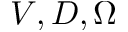Convert formula to latex. <formula><loc_0><loc_0><loc_500><loc_500>V , D , \Omega</formula> 